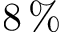<formula> <loc_0><loc_0><loc_500><loc_500>8 \, \%</formula> 